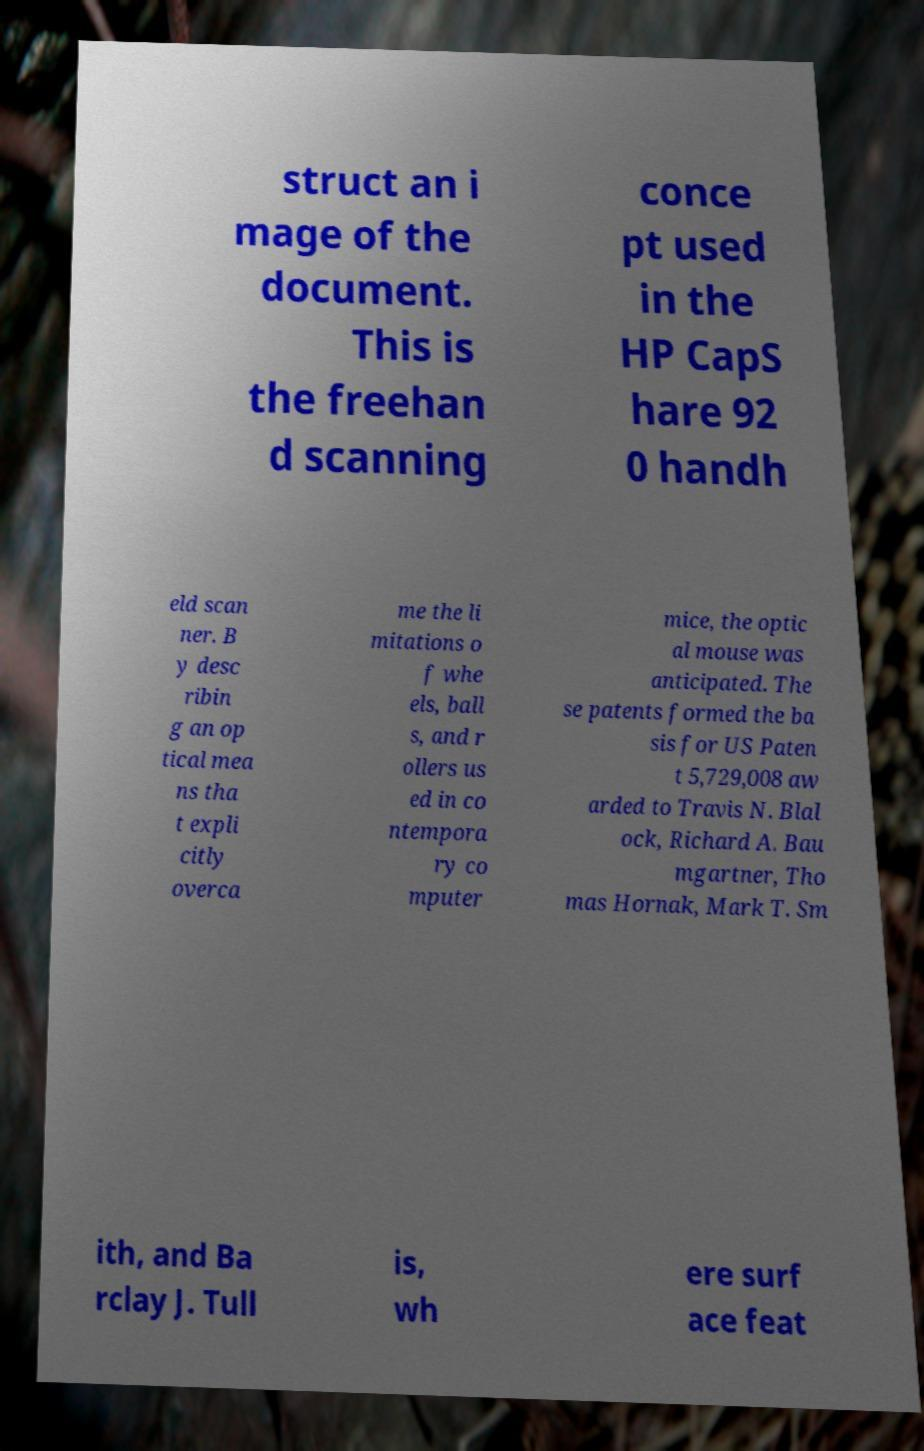Could you extract and type out the text from this image? struct an i mage of the document. This is the freehan d scanning conce pt used in the HP CapS hare 92 0 handh eld scan ner. B y desc ribin g an op tical mea ns tha t expli citly overca me the li mitations o f whe els, ball s, and r ollers us ed in co ntempora ry co mputer mice, the optic al mouse was anticipated. The se patents formed the ba sis for US Paten t 5,729,008 aw arded to Travis N. Blal ock, Richard A. Bau mgartner, Tho mas Hornak, Mark T. Sm ith, and Ba rclay J. Tull is, wh ere surf ace feat 